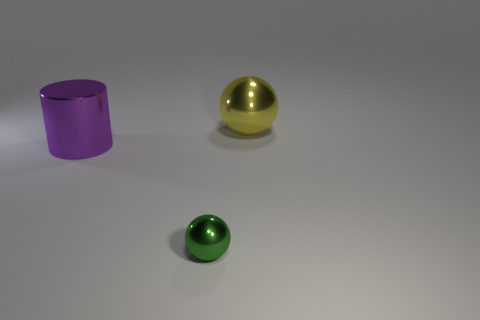Add 1 gray shiny cylinders. How many objects exist? 4 Subtract all spheres. How many objects are left? 1 Subtract all purple cylinders. Subtract all small objects. How many objects are left? 1 Add 3 tiny green balls. How many tiny green balls are left? 4 Add 2 balls. How many balls exist? 4 Subtract 0 yellow cylinders. How many objects are left? 3 